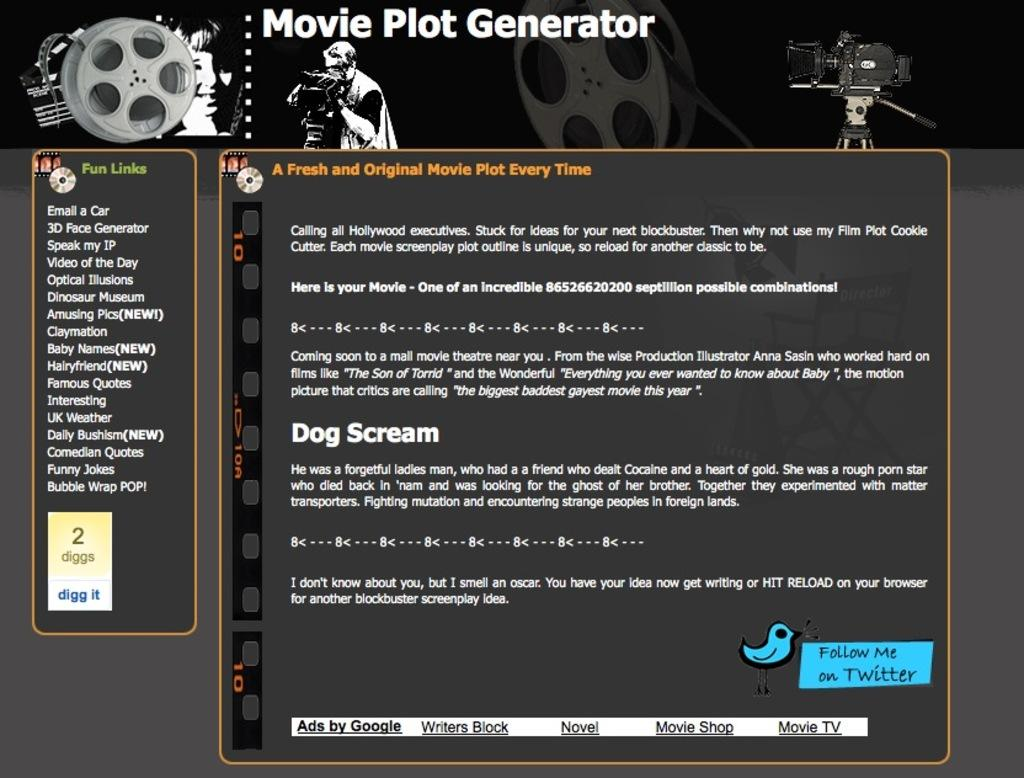What is present on the poster in the image? The poster contains text and pictures. Can you describe the content of the poster? The poster contains text and pictures, but the specific content cannot be determined from the provided facts. How many cacti are depicted on the poster? There is no information about cacti on the poster, as it only contains text and pictures. 